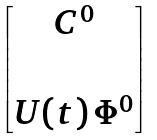<formula> <loc_0><loc_0><loc_500><loc_500>\begin{bmatrix} C ^ { 0 } \\ \\ U ( t ) \, \Phi ^ { 0 } \end{bmatrix}</formula> 